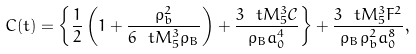Convert formula to latex. <formula><loc_0><loc_0><loc_500><loc_500>C ( t ) = \left \{ \frac { 1 } { 2 } \left ( 1 + \frac { \rho ^ { 2 } _ { b } } { 6 \ t { M } _ { 5 } ^ { 3 } \rho _ { B } } \right ) + \frac { 3 \ t { M } _ { 5 } ^ { 3 } \mathcal { C } } { \rho _ { B } a _ { 0 } ^ { 4 } } \right \} + \frac { 3 \ t { M } _ { 5 } ^ { 3 } F ^ { 2 } } { \rho _ { B } \rho ^ { 2 } _ { b } a _ { 0 } ^ { 8 } } ,</formula> 